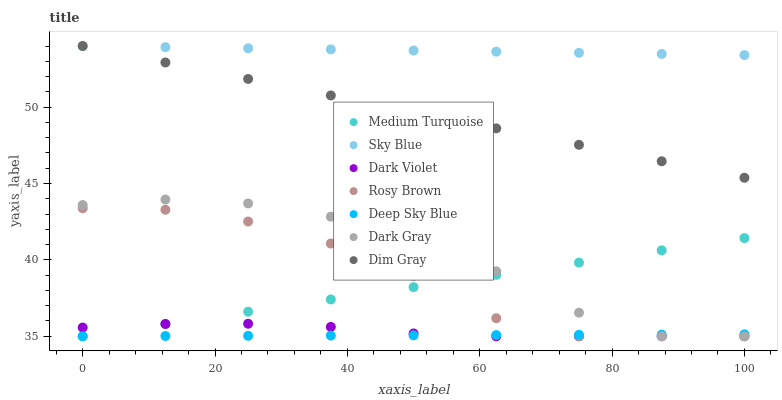Does Deep Sky Blue have the minimum area under the curve?
Answer yes or no. Yes. Does Sky Blue have the maximum area under the curve?
Answer yes or no. Yes. Does Rosy Brown have the minimum area under the curve?
Answer yes or no. No. Does Rosy Brown have the maximum area under the curve?
Answer yes or no. No. Is Deep Sky Blue the smoothest?
Answer yes or no. Yes. Is Dark Gray the roughest?
Answer yes or no. Yes. Is Rosy Brown the smoothest?
Answer yes or no. No. Is Rosy Brown the roughest?
Answer yes or no. No. Does Deep Sky Blue have the lowest value?
Answer yes or no. Yes. Does Sky Blue have the lowest value?
Answer yes or no. No. Does Sky Blue have the highest value?
Answer yes or no. Yes. Does Rosy Brown have the highest value?
Answer yes or no. No. Is Dark Gray less than Sky Blue?
Answer yes or no. Yes. Is Dim Gray greater than Dark Gray?
Answer yes or no. Yes. Does Dark Gray intersect Deep Sky Blue?
Answer yes or no. Yes. Is Dark Gray less than Deep Sky Blue?
Answer yes or no. No. Is Dark Gray greater than Deep Sky Blue?
Answer yes or no. No. Does Dark Gray intersect Sky Blue?
Answer yes or no. No. 